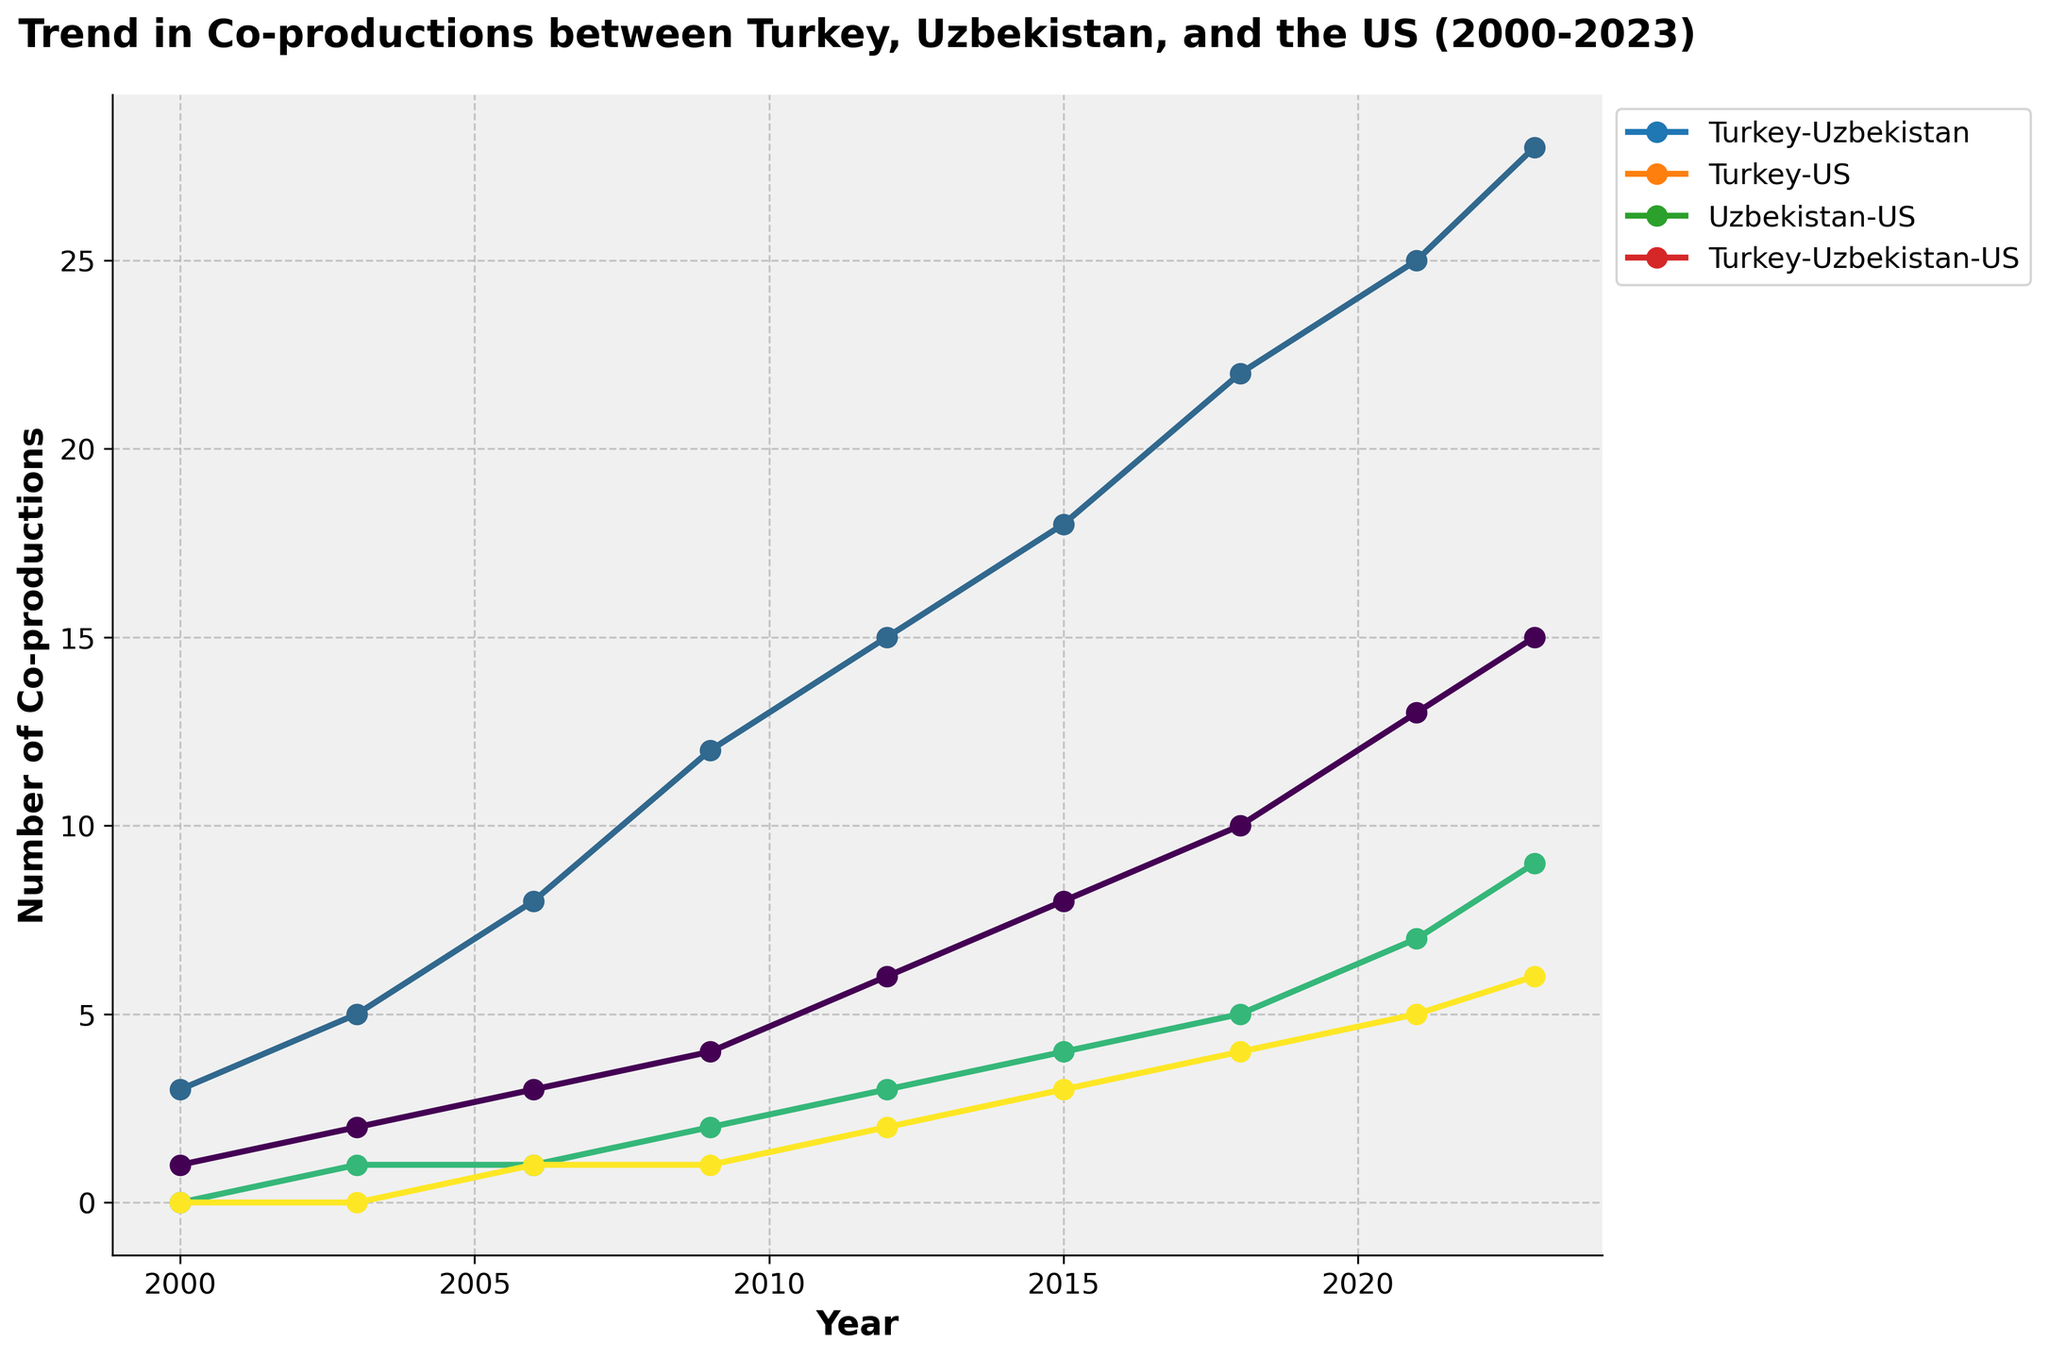What's the trend in the number of co-productions between Turkey and Uzbekistan from 2000 to 2023? The line for Turkey-Uzbekistan shows a steady increase from 1 in 2000 to 15 in 2023. This indicates a positive trend in co-productions between these two countries.
Answer: Steady increase Which collaboration had the highest number of co-productions in 2023? Look at the y-axis value for each line at the year 2023. Turkey-US had the highest, with 28 co-productions.
Answer: Turkey-US How does the number of Turkey-Uzbekistan-US co-productions in 2021 compare to 2015? Refer to the values indicated by the Turkey-Uzbekistan-US line for 2015 and 2021. It increases from 3 in 2015 to 5 in 2021.
Answer: Increased by 2 Between which years did the Turkey-US co-productions see the most significant increase? Examine the differences in y-values for Turkey-US between consecutive years. The largest increase is from 2006 (8) to 2009 (12), which is a difference of 4.
Answer: 2006 to 2009 What is the average number of co-productions between Turkey and Uzbekistan over the entire period? Sum the values for Turkey-Uzbekistan (1 + 2 + 3 + 4 + 6 + 8 + 10 + 13 + 15) and divide by the number of years (9). Calculations: (1+2+3+4+6+8+10+13+15) = 62/9 = 6.89.
Answer: 6.89 Which type of co-production shows a slower growth initially but rises more sharply after 2015? Compare each trend line's slope before and after 2015. Turkey-US shows slower growth initially, but significantly steeper growth post-2015.
Answer: Turkey-US In which year were there more Uzbekistan-US co-productions, 2006 or 2018? Compare the y-values for the Uzbekistan-US line between 2006 and 2018. It shows 1 in 2006 and 5 in 2018.
Answer: 2018 By how much did the total number of co-productions increase from 2000 to 2023? Sum the values for each co-production category in 2000 (1+3+0+0) and 2023 (15+28+9+6), then find the difference between these sums. Calculations: (15+28+9+6) - (1+3+0+0) = 58 - 4 = 54.
Answer: Increased by 54 When did the Turkey-Uzbekistan-US co-productions first appear, and how did they progress afterward? The Turkey-Uzbekistan-US line starts in 2006 with a value of 1. From there, it grows steadily to 6 by 2023.
Answer: 2006, steady growth Which collaboration had exactly zero co-productions in the initial years, and did it eventually increase? The Uzbekistan-US line shows zero co-productions in 2000, but eventually increases to 9 by 2023.
Answer: Uzbekistan-US, Yes 